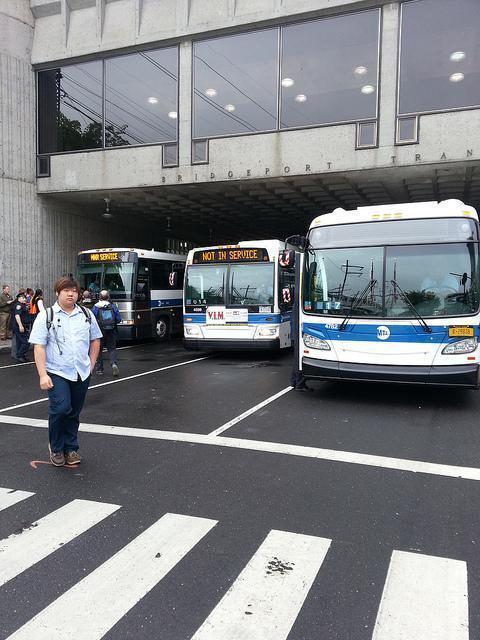What's the name of the area the asian man is near?
Choose the correct response, then elucidate: 'Answer: answer
Rationale: rationale.'
Options: Cross walk, terminal b, terminal, pickup zone. Answer: cross walk.
Rationale: This is indicated by the white stripes. 